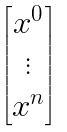<formula> <loc_0><loc_0><loc_500><loc_500>\begin{bmatrix} x ^ { 0 } \\ \vdots \\ x ^ { n } \\ \end{bmatrix}</formula> 